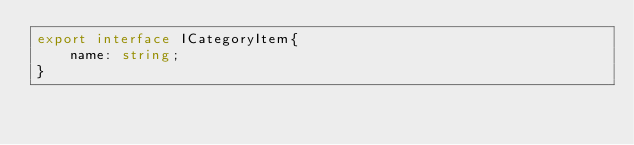Convert code to text. <code><loc_0><loc_0><loc_500><loc_500><_TypeScript_>export interface ICategoryItem{
    name: string;
}</code> 